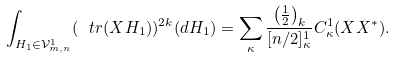<formula> <loc_0><loc_0><loc_500><loc_500>\int _ { H _ { 1 } \in \mathcal { V } ^ { 1 } _ { m , n } } ( \ t r ( X H _ { 1 } ) ) ^ { 2 k } ( d H _ { 1 } ) = \sum _ { \kappa } \frac { \left ( \frac { 1 } { 2 } \right ) _ { k } } { [ n / 2 ] ^ { 1 } _ { \kappa } } C ^ { 1 } _ { \kappa } ( X X ^ { * } ) .</formula> 